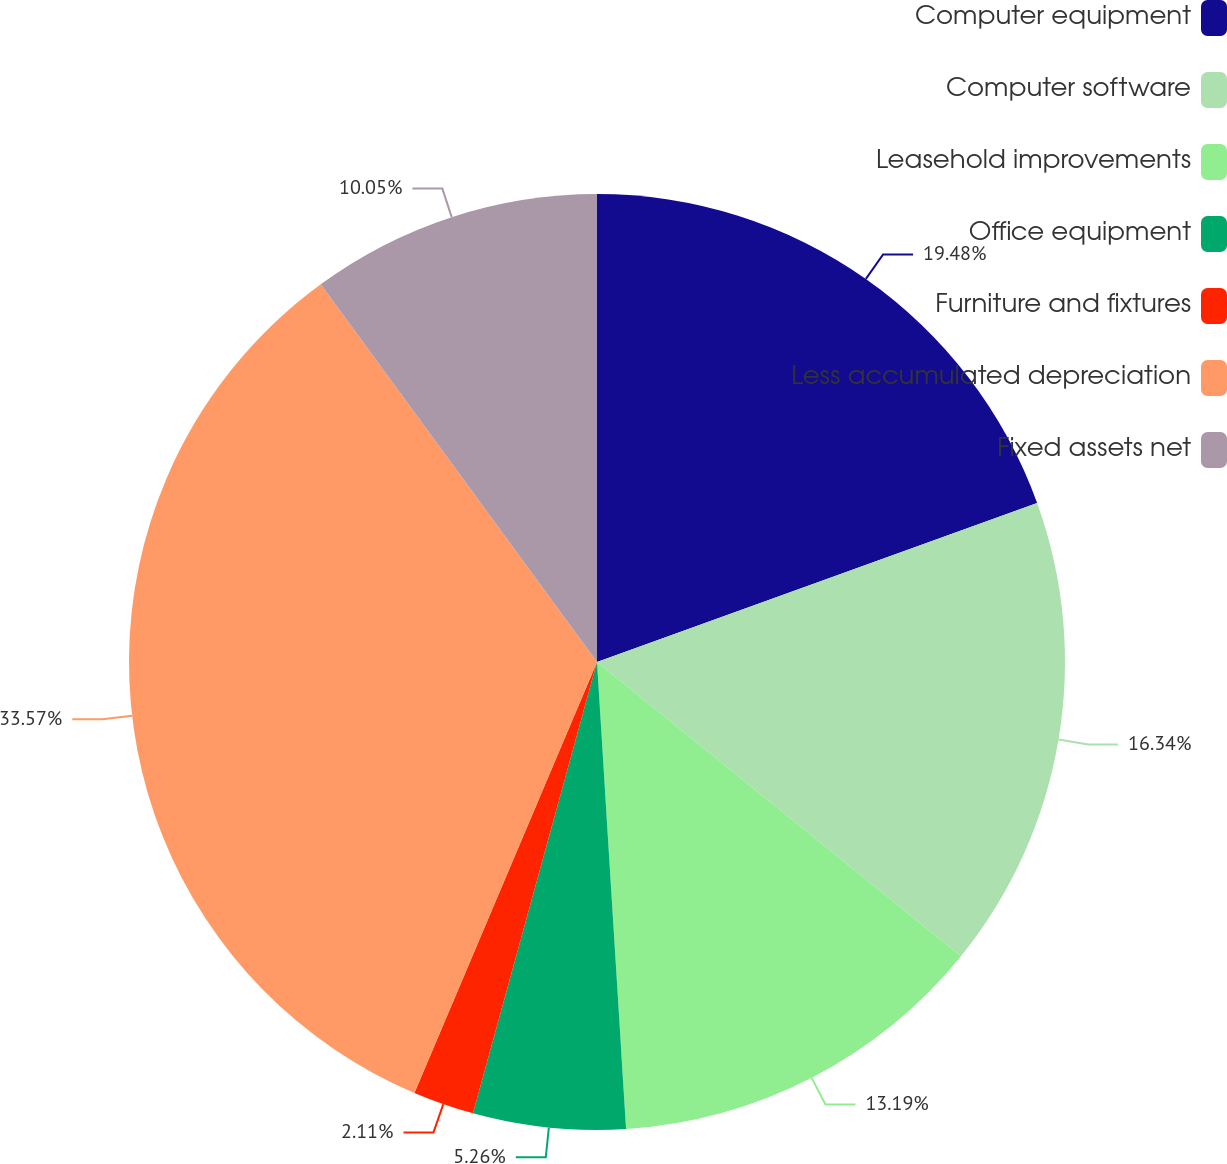Convert chart to OTSL. <chart><loc_0><loc_0><loc_500><loc_500><pie_chart><fcel>Computer equipment<fcel>Computer software<fcel>Leasehold improvements<fcel>Office equipment<fcel>Furniture and fixtures<fcel>Less accumulated depreciation<fcel>Fixed assets net<nl><fcel>19.48%<fcel>16.34%<fcel>13.19%<fcel>5.26%<fcel>2.11%<fcel>33.57%<fcel>10.05%<nl></chart> 